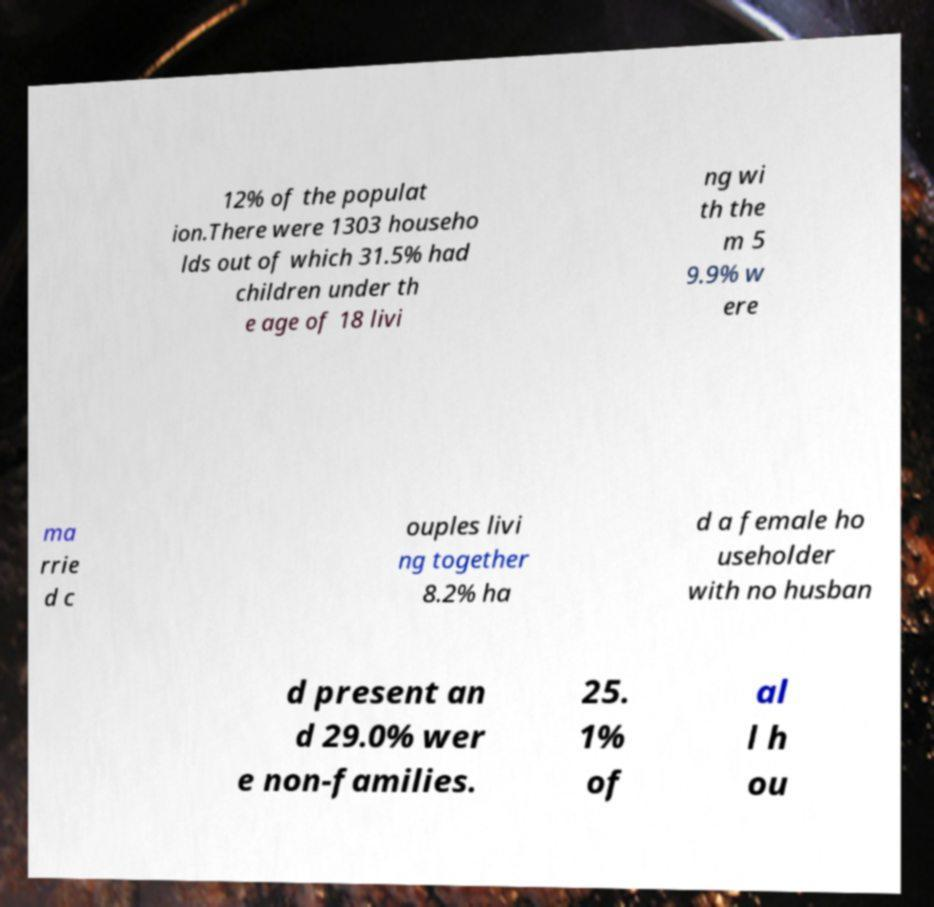Could you assist in decoding the text presented in this image and type it out clearly? 12% of the populat ion.There were 1303 househo lds out of which 31.5% had children under th e age of 18 livi ng wi th the m 5 9.9% w ere ma rrie d c ouples livi ng together 8.2% ha d a female ho useholder with no husban d present an d 29.0% wer e non-families. 25. 1% of al l h ou 